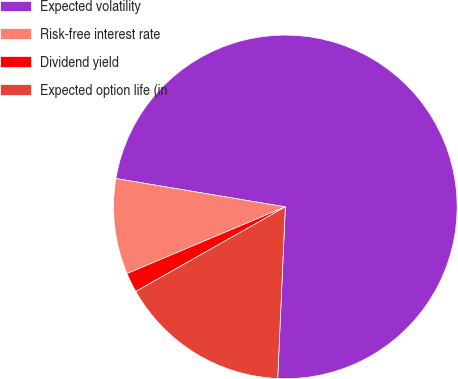Convert chart to OTSL. <chart><loc_0><loc_0><loc_500><loc_500><pie_chart><fcel>Expected volatility<fcel>Risk-free interest rate<fcel>Dividend yield<fcel>Expected option life (in<nl><fcel>73.07%<fcel>8.98%<fcel>1.85%<fcel>16.1%<nl></chart> 